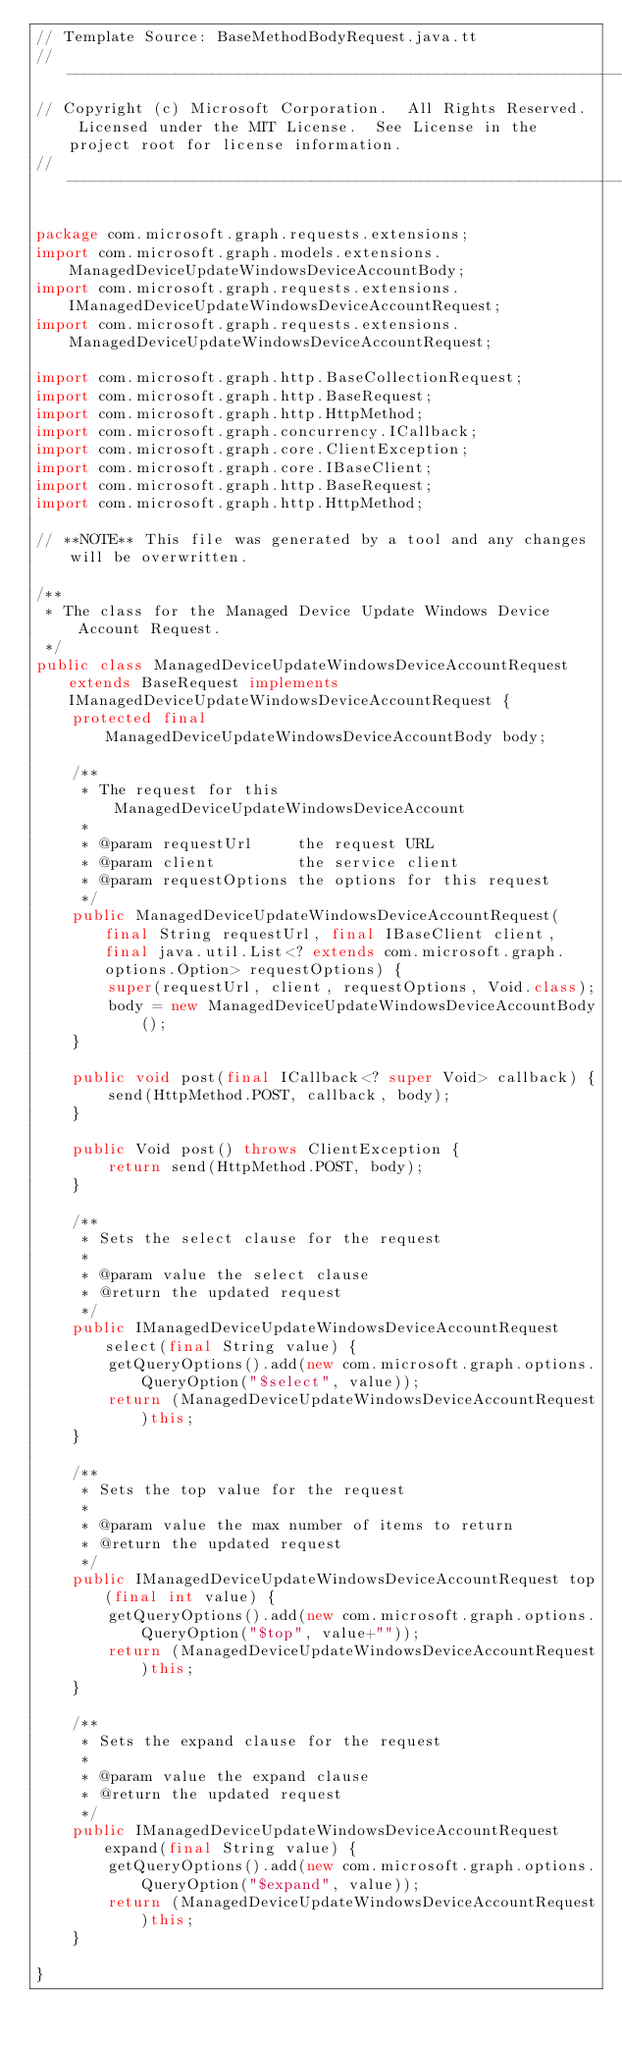Convert code to text. <code><loc_0><loc_0><loc_500><loc_500><_Java_>// Template Source: BaseMethodBodyRequest.java.tt
// ------------------------------------------------------------------------------
// Copyright (c) Microsoft Corporation.  All Rights Reserved.  Licensed under the MIT License.  See License in the project root for license information.
// ------------------------------------------------------------------------------

package com.microsoft.graph.requests.extensions;
import com.microsoft.graph.models.extensions.ManagedDeviceUpdateWindowsDeviceAccountBody;
import com.microsoft.graph.requests.extensions.IManagedDeviceUpdateWindowsDeviceAccountRequest;
import com.microsoft.graph.requests.extensions.ManagedDeviceUpdateWindowsDeviceAccountRequest;

import com.microsoft.graph.http.BaseCollectionRequest;
import com.microsoft.graph.http.BaseRequest;
import com.microsoft.graph.http.HttpMethod;
import com.microsoft.graph.concurrency.ICallback;
import com.microsoft.graph.core.ClientException;
import com.microsoft.graph.core.IBaseClient;
import com.microsoft.graph.http.BaseRequest;
import com.microsoft.graph.http.HttpMethod;

// **NOTE** This file was generated by a tool and any changes will be overwritten.

/**
 * The class for the Managed Device Update Windows Device Account Request.
 */
public class ManagedDeviceUpdateWindowsDeviceAccountRequest extends BaseRequest implements IManagedDeviceUpdateWindowsDeviceAccountRequest {
    protected final ManagedDeviceUpdateWindowsDeviceAccountBody body;

    /**
     * The request for this ManagedDeviceUpdateWindowsDeviceAccount
     *
     * @param requestUrl     the request URL
     * @param client         the service client
     * @param requestOptions the options for this request
     */
    public ManagedDeviceUpdateWindowsDeviceAccountRequest(final String requestUrl, final IBaseClient client, final java.util.List<? extends com.microsoft.graph.options.Option> requestOptions) {
        super(requestUrl, client, requestOptions, Void.class);
        body = new ManagedDeviceUpdateWindowsDeviceAccountBody();
    }

    public void post(final ICallback<? super Void> callback) {
        send(HttpMethod.POST, callback, body);
    }

    public Void post() throws ClientException {
        return send(HttpMethod.POST, body);
    }

    /**
     * Sets the select clause for the request
     *
     * @param value the select clause
     * @return the updated request
     */
    public IManagedDeviceUpdateWindowsDeviceAccountRequest select(final String value) {
        getQueryOptions().add(new com.microsoft.graph.options.QueryOption("$select", value));
        return (ManagedDeviceUpdateWindowsDeviceAccountRequest)this;
    }

    /**
     * Sets the top value for the request
     *
     * @param value the max number of items to return
     * @return the updated request
     */
    public IManagedDeviceUpdateWindowsDeviceAccountRequest top(final int value) {
        getQueryOptions().add(new com.microsoft.graph.options.QueryOption("$top", value+""));
        return (ManagedDeviceUpdateWindowsDeviceAccountRequest)this;
    }

    /**
     * Sets the expand clause for the request
     *
     * @param value the expand clause
     * @return the updated request
     */
    public IManagedDeviceUpdateWindowsDeviceAccountRequest expand(final String value) {
        getQueryOptions().add(new com.microsoft.graph.options.QueryOption("$expand", value));
        return (ManagedDeviceUpdateWindowsDeviceAccountRequest)this;
    }

}
</code> 